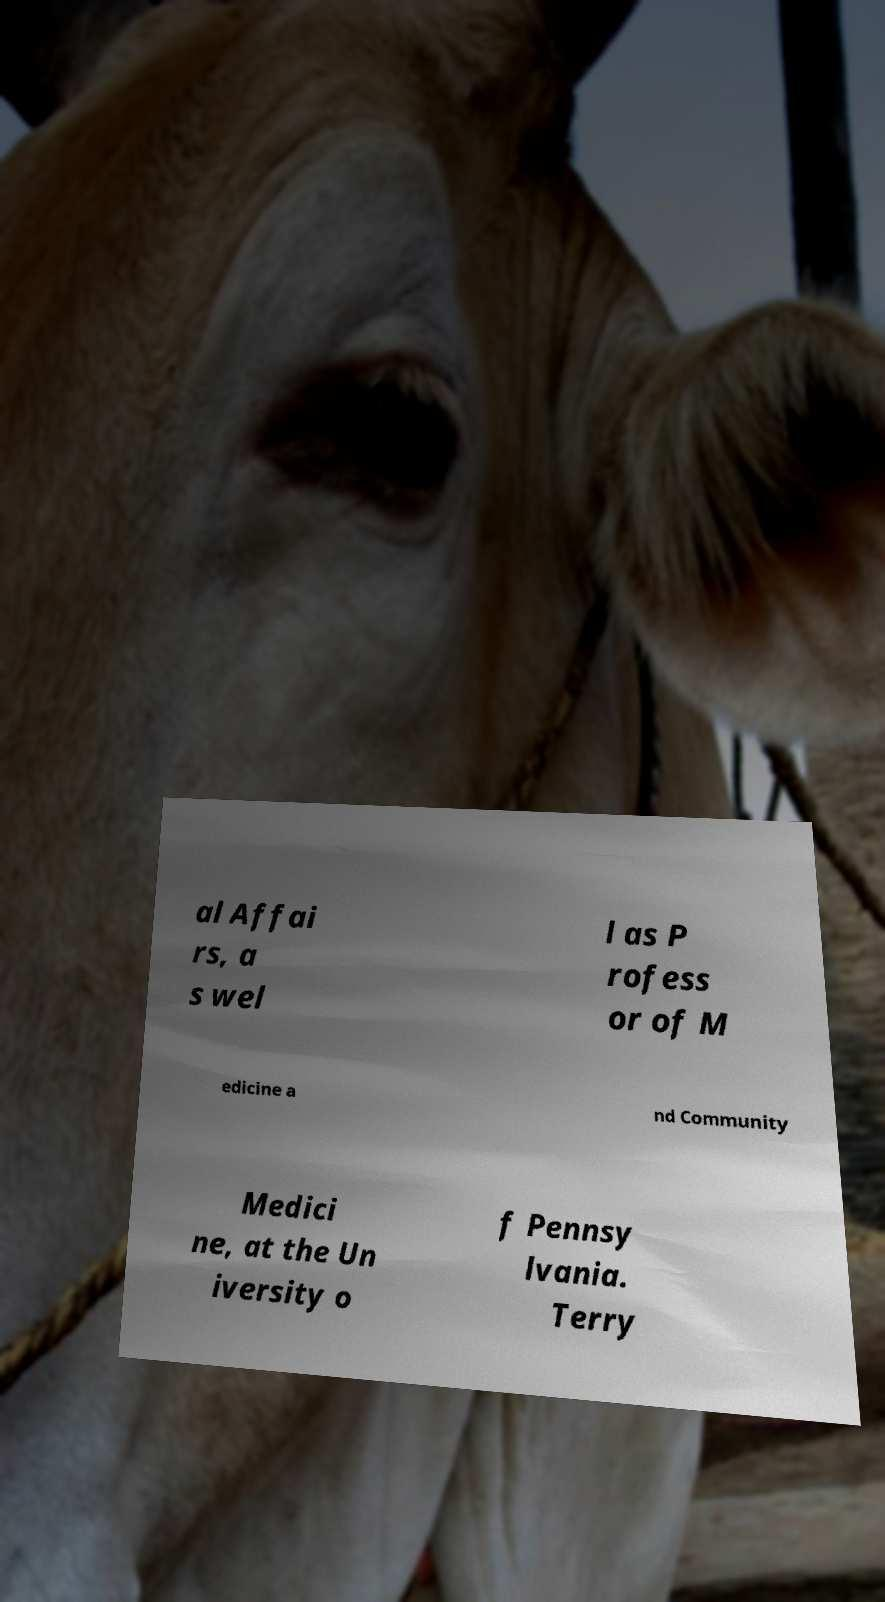Could you assist in decoding the text presented in this image and type it out clearly? al Affai rs, a s wel l as P rofess or of M edicine a nd Community Medici ne, at the Un iversity o f Pennsy lvania. Terry 